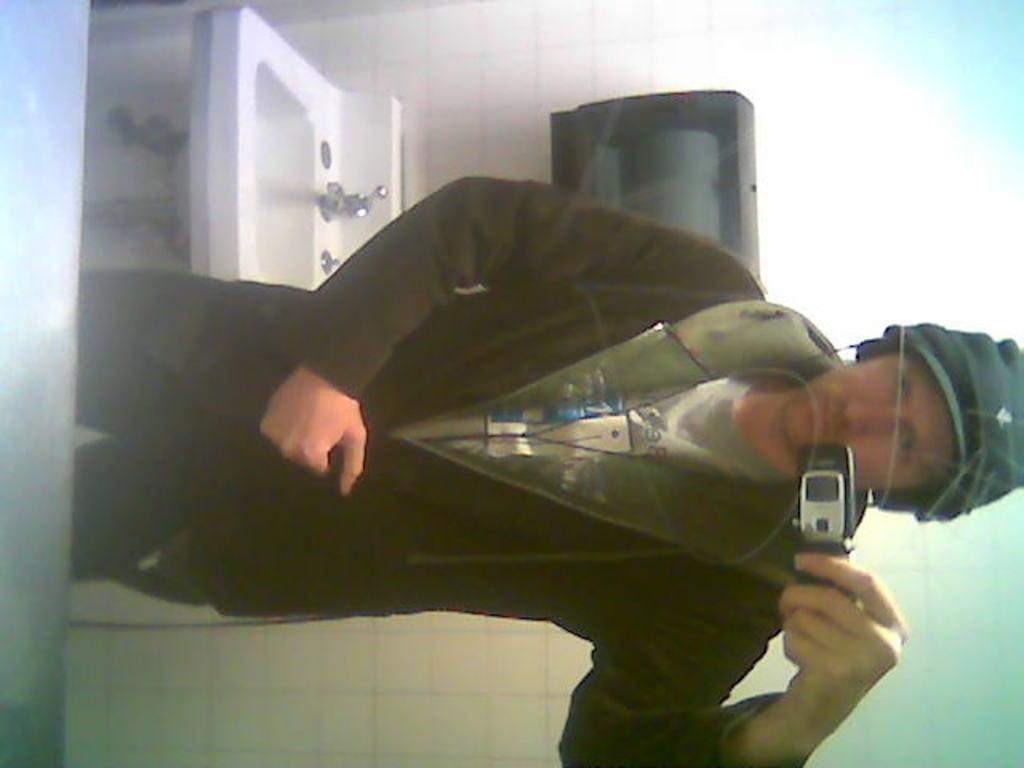Who or what is present in the image? There is a person in the image. What is the person holding in the image? The person is holding a mobile phone. What can be seen in the background of the image? There is a wall in the background of the image. What is on the wall in the image? There is an object on the wall. What can be used for washing or cleaning in the image? There is a sink visible in the image. What type of science experiment is being conducted with the pickle in the image? There is no pickle present in the image, and therefore no science experiment can be observed. Is the person wearing a crown in the image? There is no crown visible in the image. 